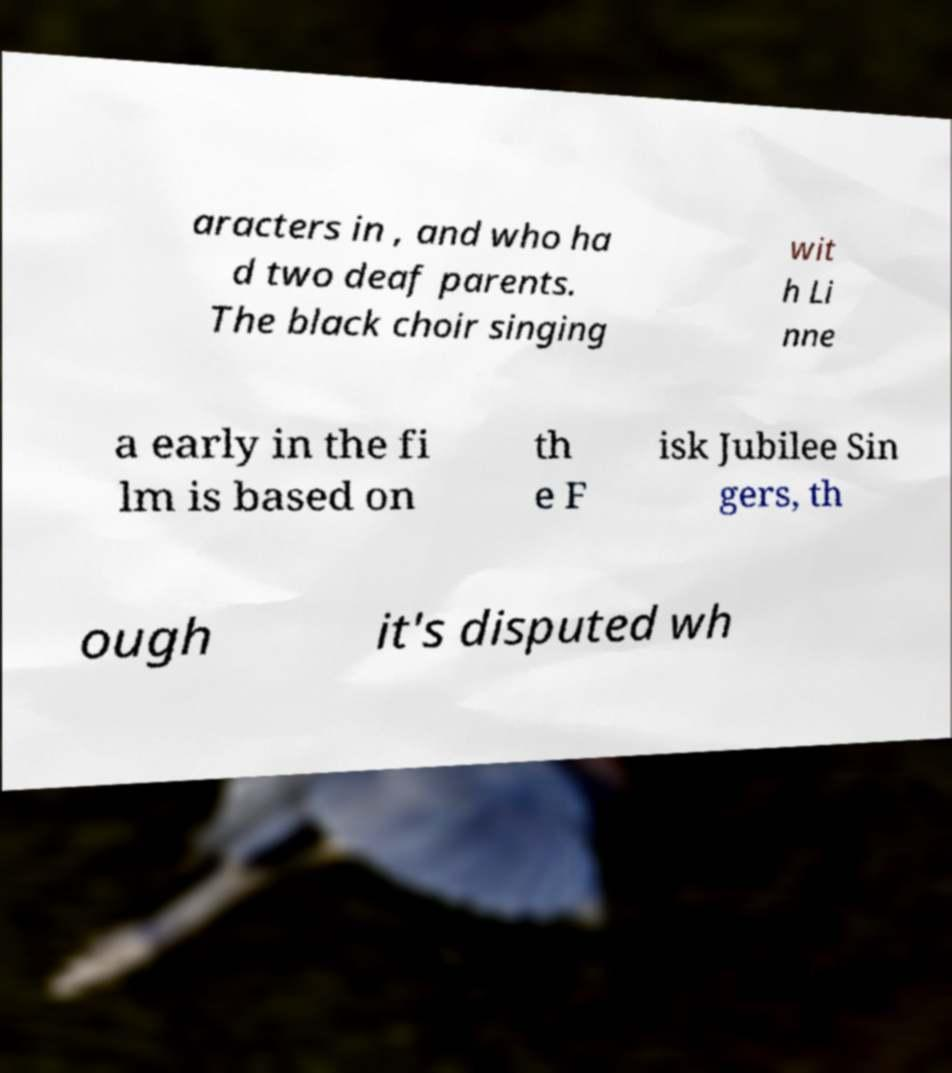Could you assist in decoding the text presented in this image and type it out clearly? aracters in , and who ha d two deaf parents. The black choir singing wit h Li nne a early in the fi lm is based on th e F isk Jubilee Sin gers, th ough it's disputed wh 